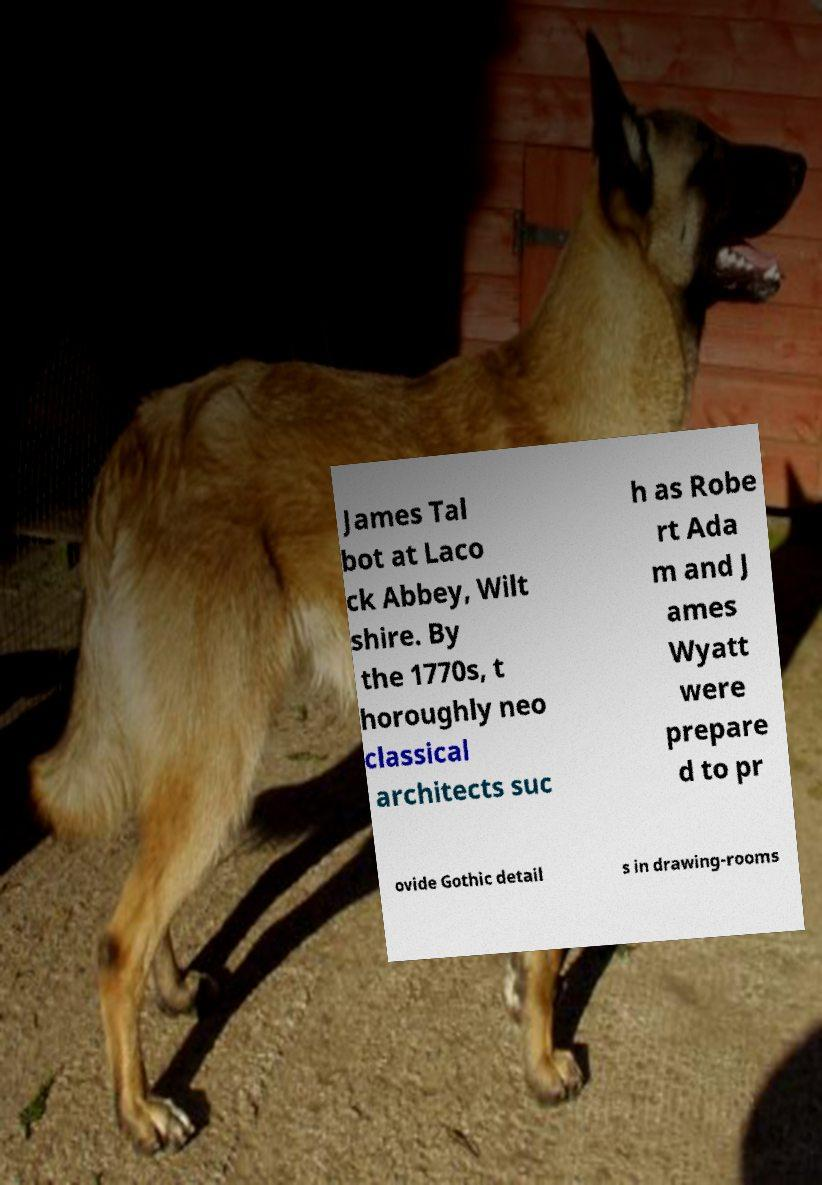Could you assist in decoding the text presented in this image and type it out clearly? James Tal bot at Laco ck Abbey, Wilt shire. By the 1770s, t horoughly neo classical architects suc h as Robe rt Ada m and J ames Wyatt were prepare d to pr ovide Gothic detail s in drawing-rooms 